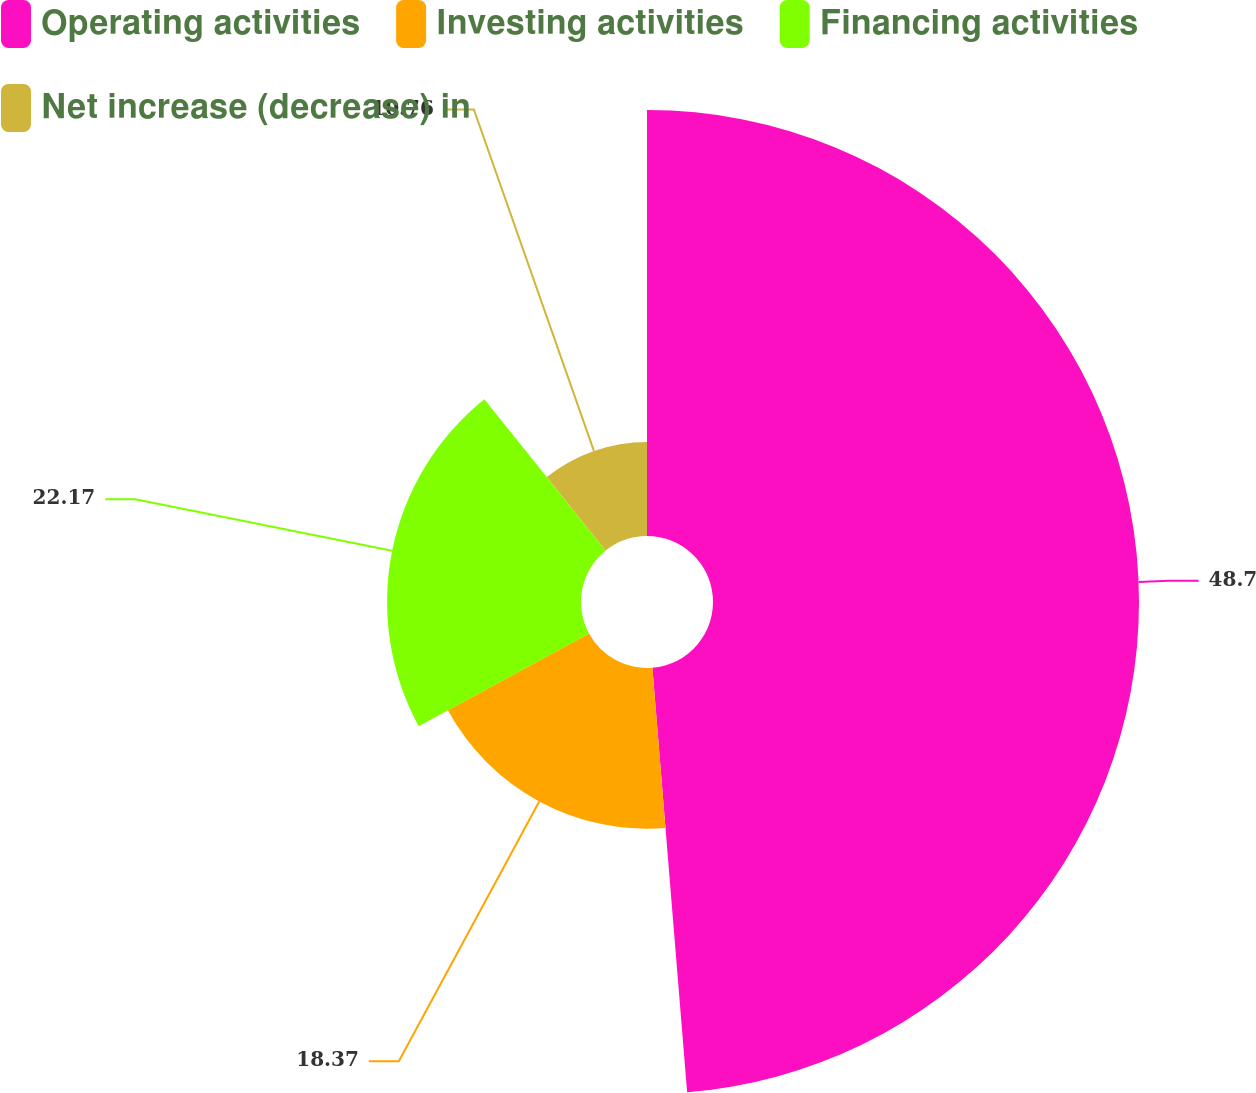<chart> <loc_0><loc_0><loc_500><loc_500><pie_chart><fcel>Operating activities<fcel>Investing activities<fcel>Financing activities<fcel>Net increase (decrease) in<nl><fcel>48.7%<fcel>18.37%<fcel>22.17%<fcel>10.76%<nl></chart> 